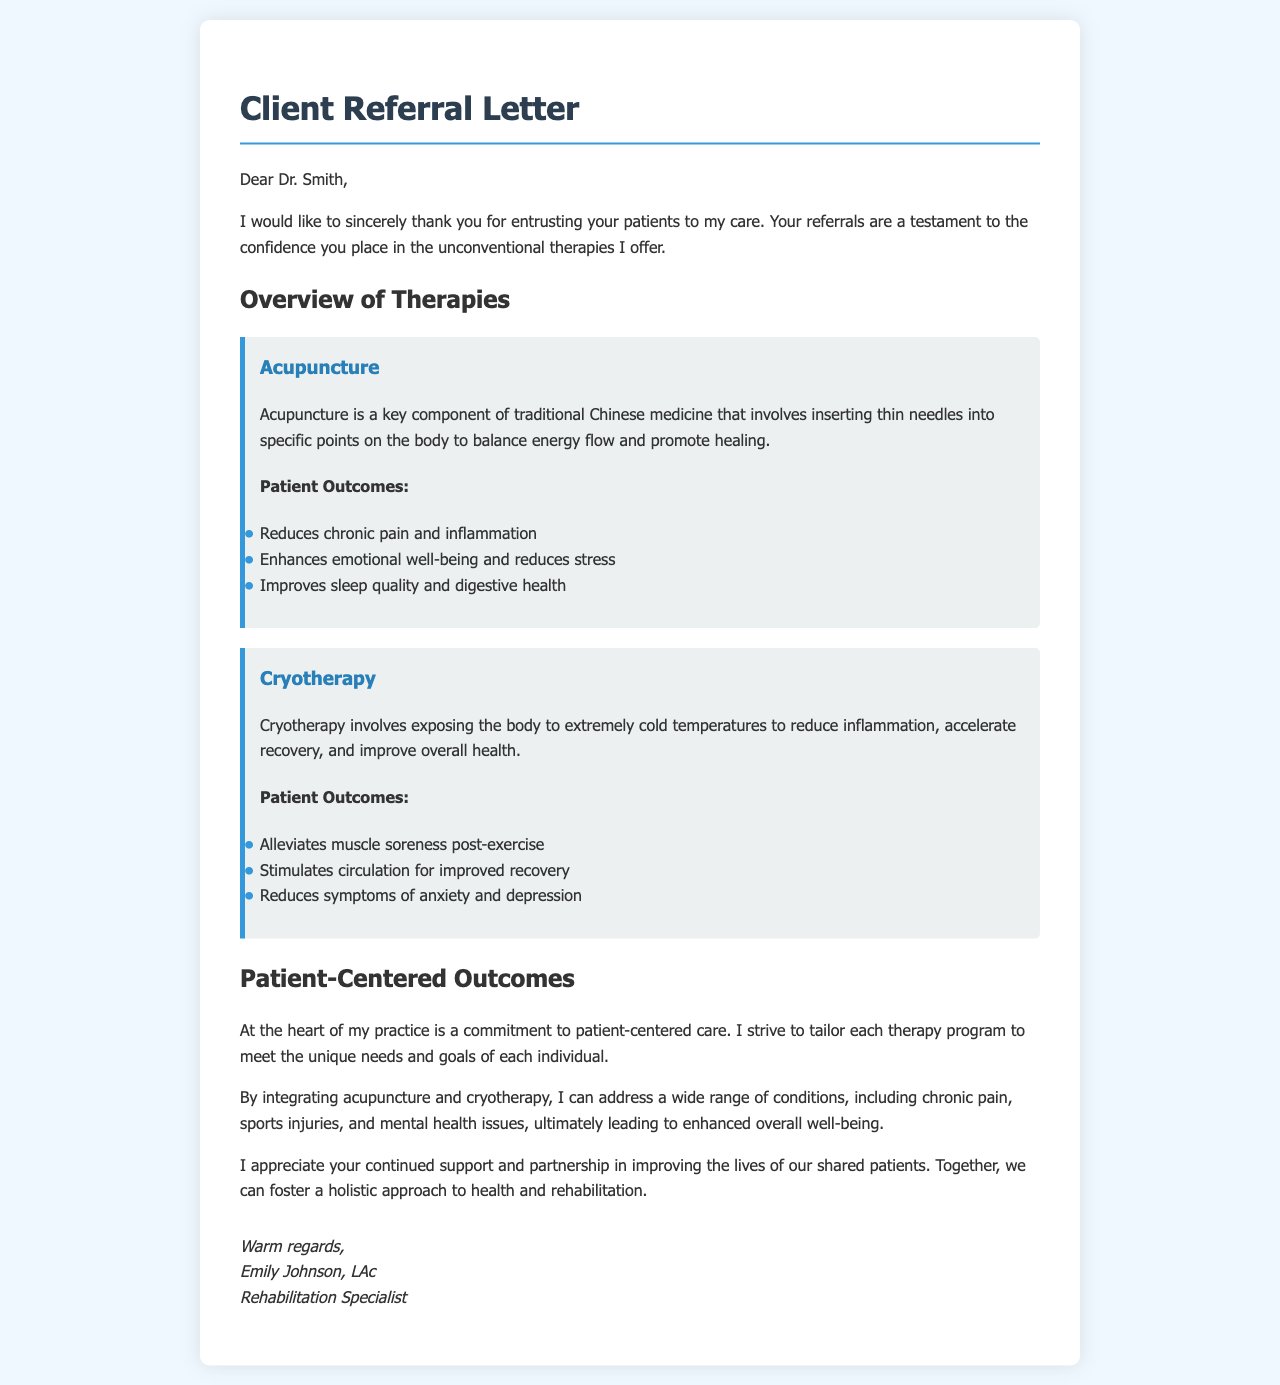What is the name of the referring physician? The referring physician's name is mentioned in the salutation of the letter.
Answer: Dr. Smith What therapies are offered in the letter? The document lists the therapies being offered in separate sections.
Answer: Acupuncture, Cryotherapy What is a key component of traditional Chinese medicine mentioned in the letter? The letter describes a specific therapy in relation to traditional Chinese medicine.
Answer: Acupuncture What is one of the patient outcomes of acupuncture? The letter provides a list of patient outcomes related to acupuncture.
Answer: Reduces chronic pain and inflammation What are two conditions addressed by integrating acupuncture and cryotherapy? The letter mentions a variety of conditions that can be treated with the therapies.
Answer: Chronic pain, sports injuries Who is the rehabilitation specialist who signed the letter? The letter concludes with the signature of the author, including their qualifications.
Answer: Emily Johnson, LAc How does the author describe their approach to therapy? The letter emphasizes a specific philosophy regarding patient care.
Answer: Patient-centered care What type of letter is this document? The document falls under a specific category of correspondence used in healthcare.
Answer: Client Referral Letter 